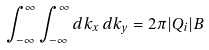<formula> <loc_0><loc_0><loc_500><loc_500>\int _ { - \infty } ^ { \infty } \int _ { - \infty } ^ { \infty } d k _ { x } \, d k _ { y } = 2 \pi | Q _ { i } | B</formula> 